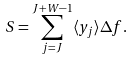<formula> <loc_0><loc_0><loc_500><loc_500>S = \sum _ { j = J } ^ { J + W - 1 } \langle y _ { j } \rangle \Delta f .</formula> 